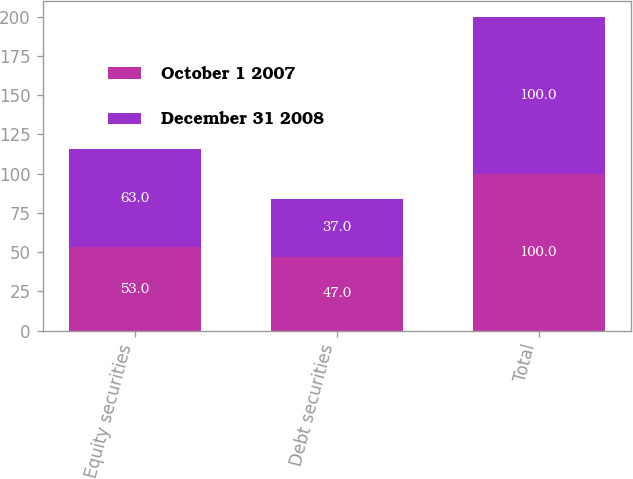Convert chart to OTSL. <chart><loc_0><loc_0><loc_500><loc_500><stacked_bar_chart><ecel><fcel>Equity securities<fcel>Debt securities<fcel>Total<nl><fcel>October 1 2007<fcel>53<fcel>47<fcel>100<nl><fcel>December 31 2008<fcel>63<fcel>37<fcel>100<nl></chart> 